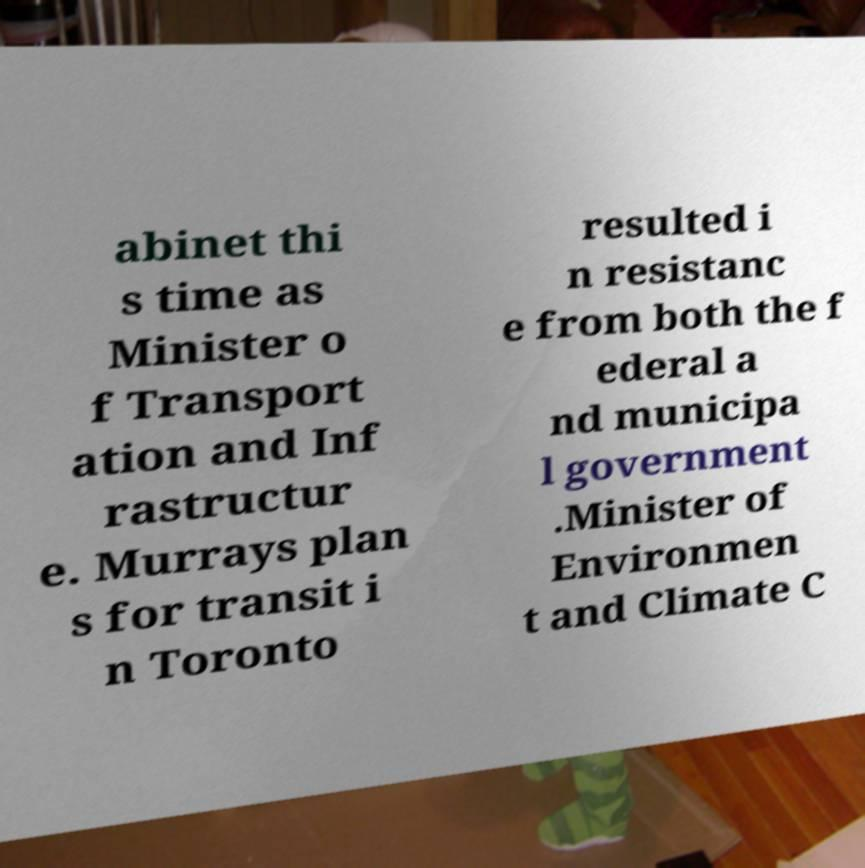For documentation purposes, I need the text within this image transcribed. Could you provide that? abinet thi s time as Minister o f Transport ation and Inf rastructur e. Murrays plan s for transit i n Toronto resulted i n resistanc e from both the f ederal a nd municipa l government .Minister of Environmen t and Climate C 